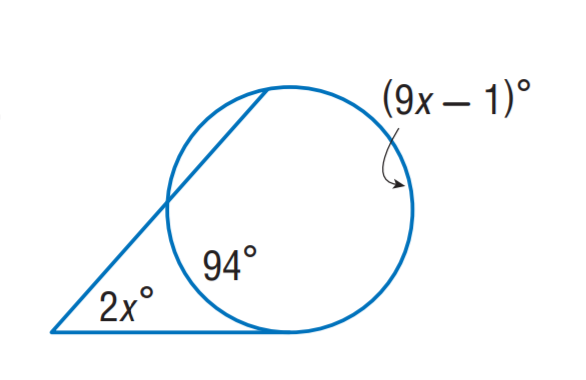Question: Find x.
Choices:
A. 13.5
B. 19
C. 23.5
D. 47
Answer with the letter. Answer: B 